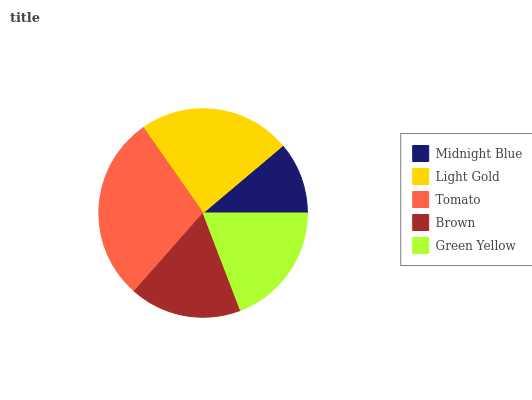Is Midnight Blue the minimum?
Answer yes or no. Yes. Is Tomato the maximum?
Answer yes or no. Yes. Is Light Gold the minimum?
Answer yes or no. No. Is Light Gold the maximum?
Answer yes or no. No. Is Light Gold greater than Midnight Blue?
Answer yes or no. Yes. Is Midnight Blue less than Light Gold?
Answer yes or no. Yes. Is Midnight Blue greater than Light Gold?
Answer yes or no. No. Is Light Gold less than Midnight Blue?
Answer yes or no. No. Is Green Yellow the high median?
Answer yes or no. Yes. Is Green Yellow the low median?
Answer yes or no. Yes. Is Tomato the high median?
Answer yes or no. No. Is Midnight Blue the low median?
Answer yes or no. No. 